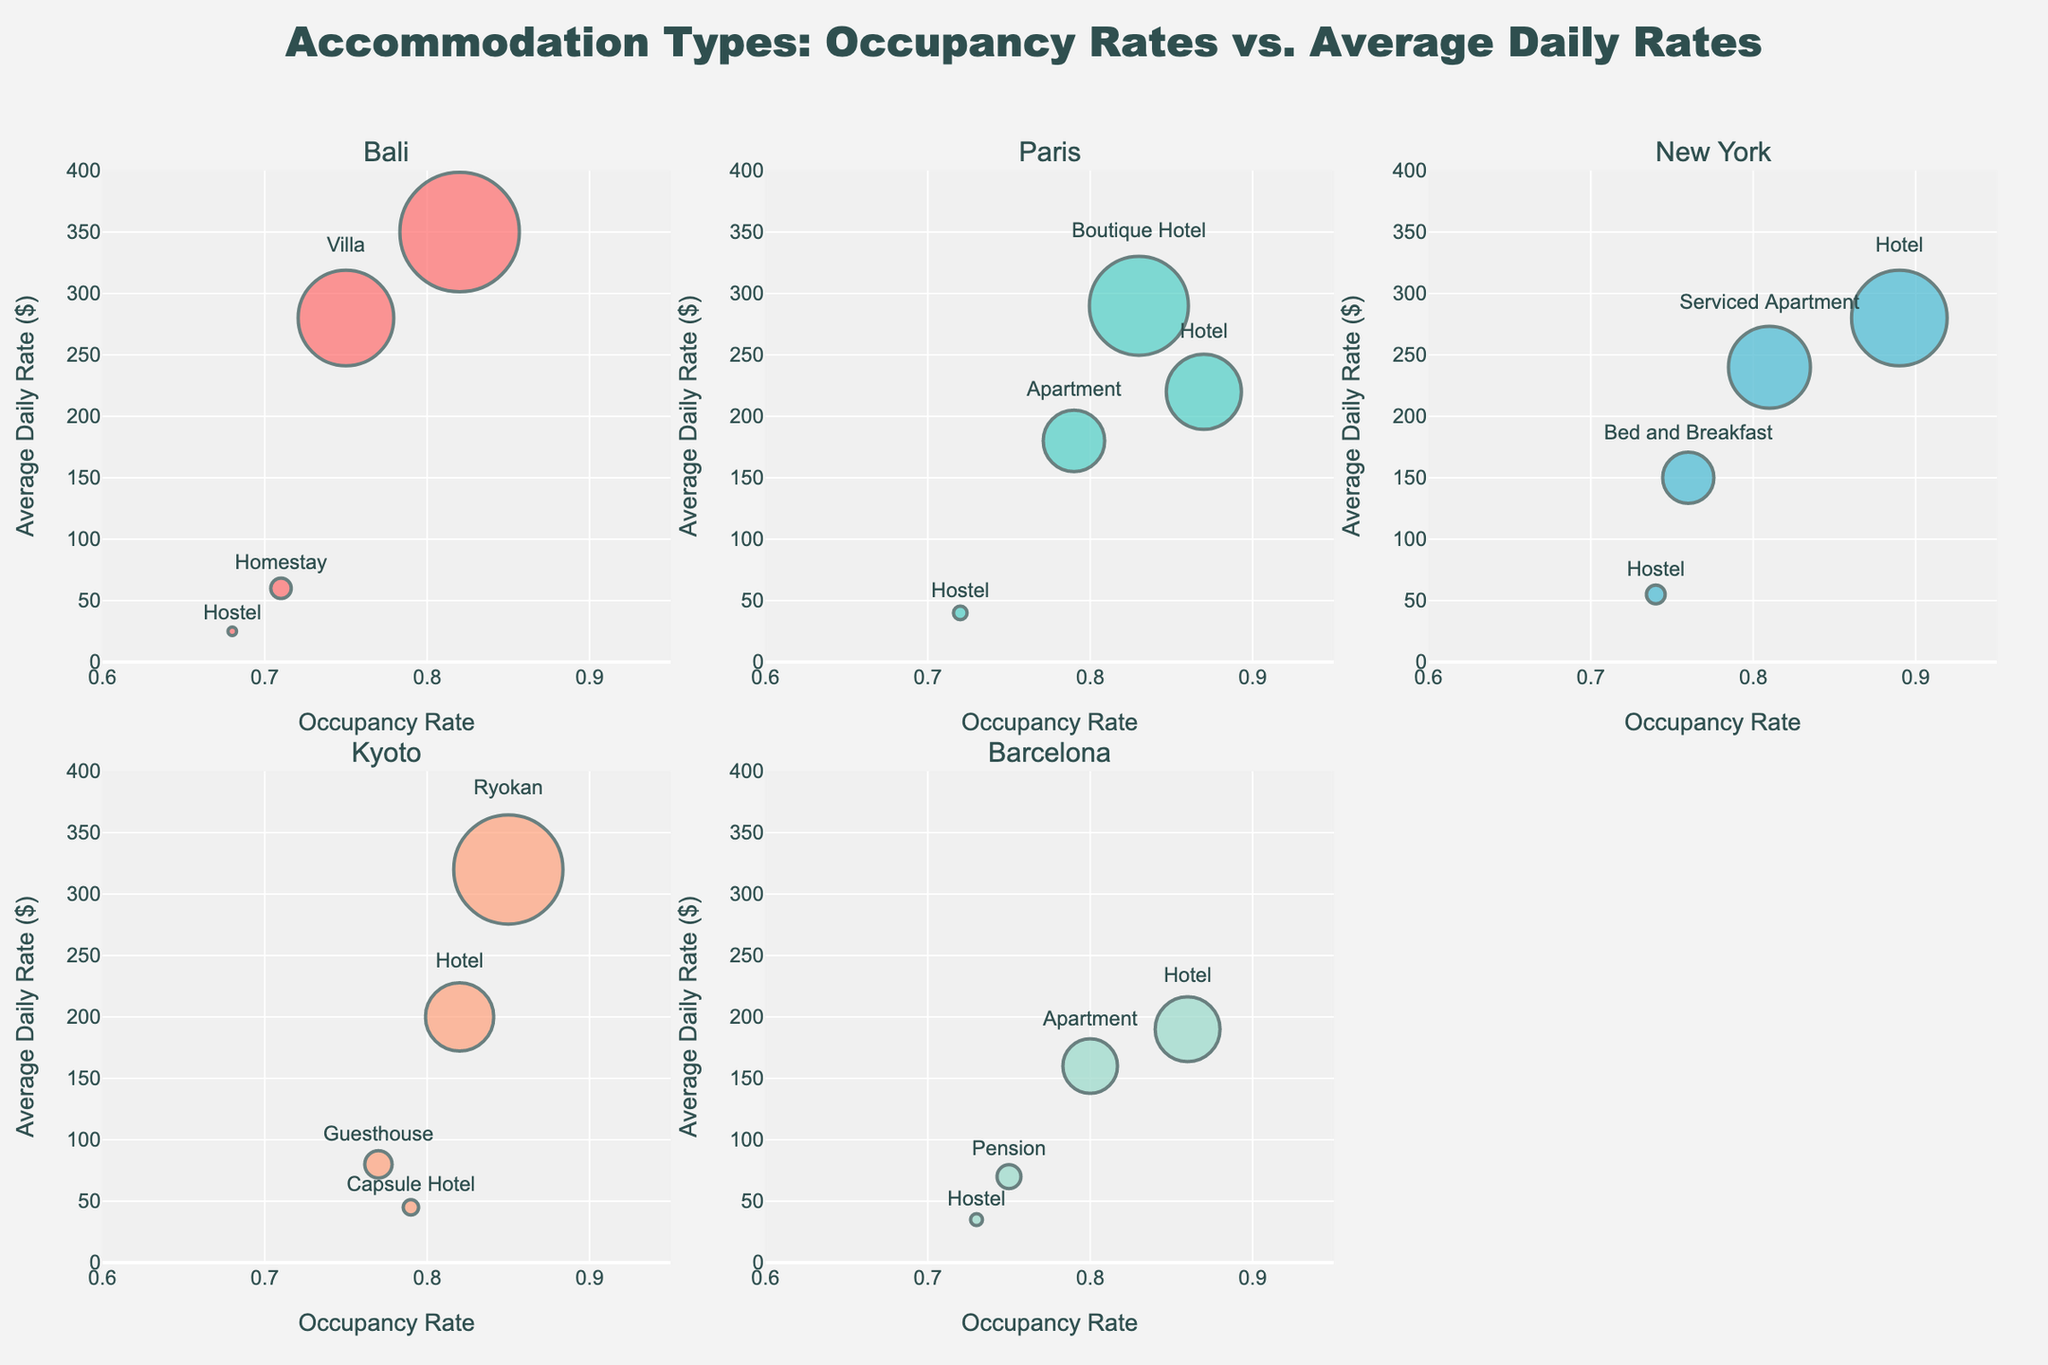What's the average daily rate of resorts in Bali? Look at the Bali subplot and find the point labeled "Resort". Its average daily rate is $350.
Answer: $350 Which destination has the highest occupancy rate for hostels? Locate the respective plots for hostels and compare their occupancy rates: Bali (0.68), Paris (0.72), New York (0.74), and Barcelona (0.73). New York has the highest occupancy rate.
Answer: New York What is the closest occupancy rate between any two accommodation types in Kyoto? Compare the occupancy rates in Kyoto: Ryokan (0.85), Hotel (0.82), Guesthouse (0.77), Capsule Hotel (0.79). The smallest difference is between Guesthouse (0.77) and Capsule Hotel (0.79).
Answer: Guesthouse and Capsule Hotel How much higher is the average daily rate of boutique hotels in Paris compared to hostels in Paris? In the Paris subplot, find the average daily rates for boutique hotels ($290) and hostels ($40). Calculate the difference: $290 - $40 = $250.
Answer: $250 Which destination has the widest range of average daily rates among its accommodation types? Compare the differences in average daily rates across destinations: Bali (Resort: 350 - Hostel: 25 = $325), Paris (Boutique Hotel: 290 - Hostel: 40 = $250), New York (Hotel: 280 - Hostel: 55 = $225), Kyoto (Ryokan: 320 - Capsule Hotel: 45 = $275), Barcelona (Hotel: 190 - Hostel: 35 = $155). Bali has the widest range.
Answer: Bali What's the average occupancy rate of all accommodations in Barcelona? Calculate the average of occupancy rates in Barcelona: (0.86 + 0.80 + 0.75 + 0.73) / 4.
Answer: 0.785 Which accommodation type has the lowest average daily rate in Kyoto? Check the Kyoto subplot to find the average daily rates for each accommodation type: Ryokan ($320), Hotel ($200), Guesthouse ($80), Capsule Hotel ($45). Capsule Hotel has the lowest rate.
Answer: Capsule Hotel Is there any accommodation type with an above 0.85 occupancy rate and an average daily rate over $300? If so, where and which type? Search all subplots for points meeting both criteria. In Kyoto, Ryokan has an occupancy rate of 0.85 and an average daily rate of $320.
Answer: Kyoto, Ryokan 